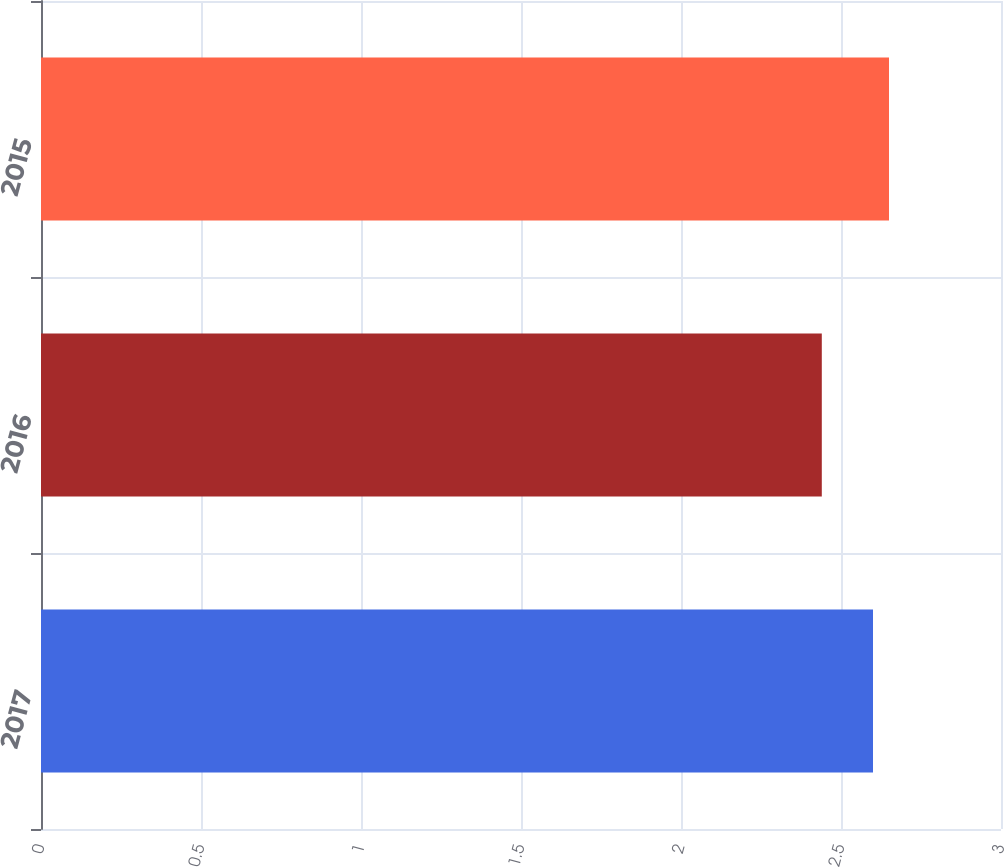<chart> <loc_0><loc_0><loc_500><loc_500><bar_chart><fcel>2017<fcel>2016<fcel>2015<nl><fcel>2.6<fcel>2.44<fcel>2.65<nl></chart> 